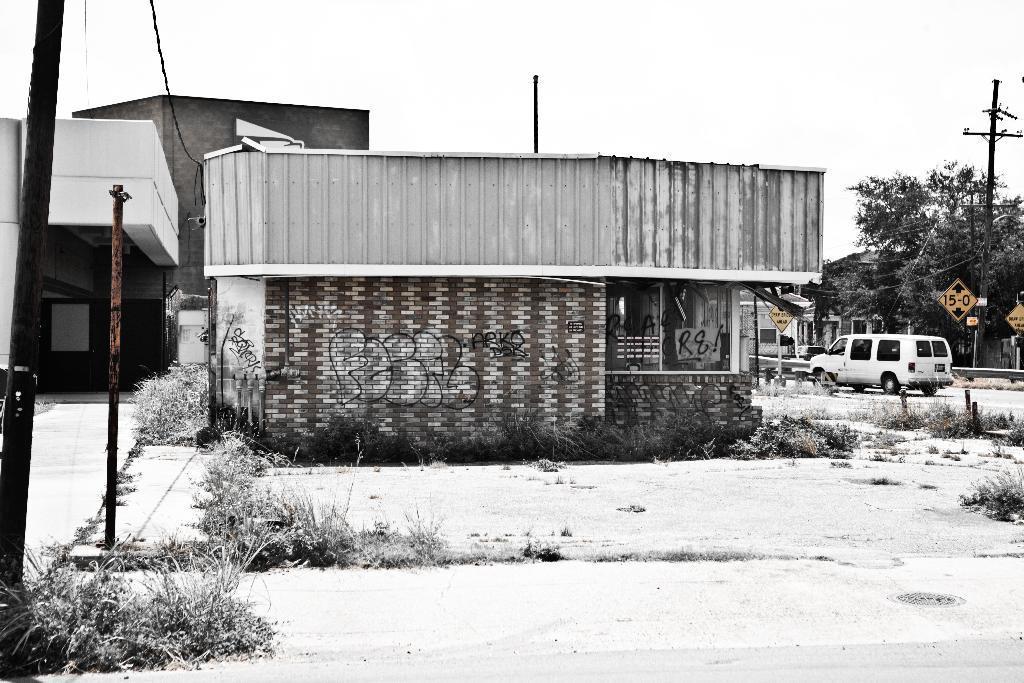Could you give a brief overview of what you see in this image? In this picture I can see the path in front, on which there are number of plants and in the middle of this picture I see number of trees, building, poles, a wire and a car. In the background I see the sky and I can also see that there is something written on the wall of a building. 